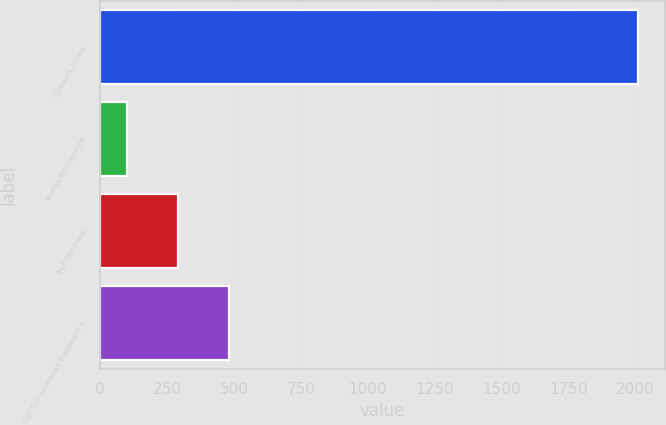<chart> <loc_0><loc_0><loc_500><loc_500><bar_chart><fcel>Company / Index<fcel>Teleflex Incorporated<fcel>S&P 500 Index<fcel>S&P 500 Healthcare Equipment &<nl><fcel>2012<fcel>100<fcel>291.2<fcel>482.4<nl></chart> 